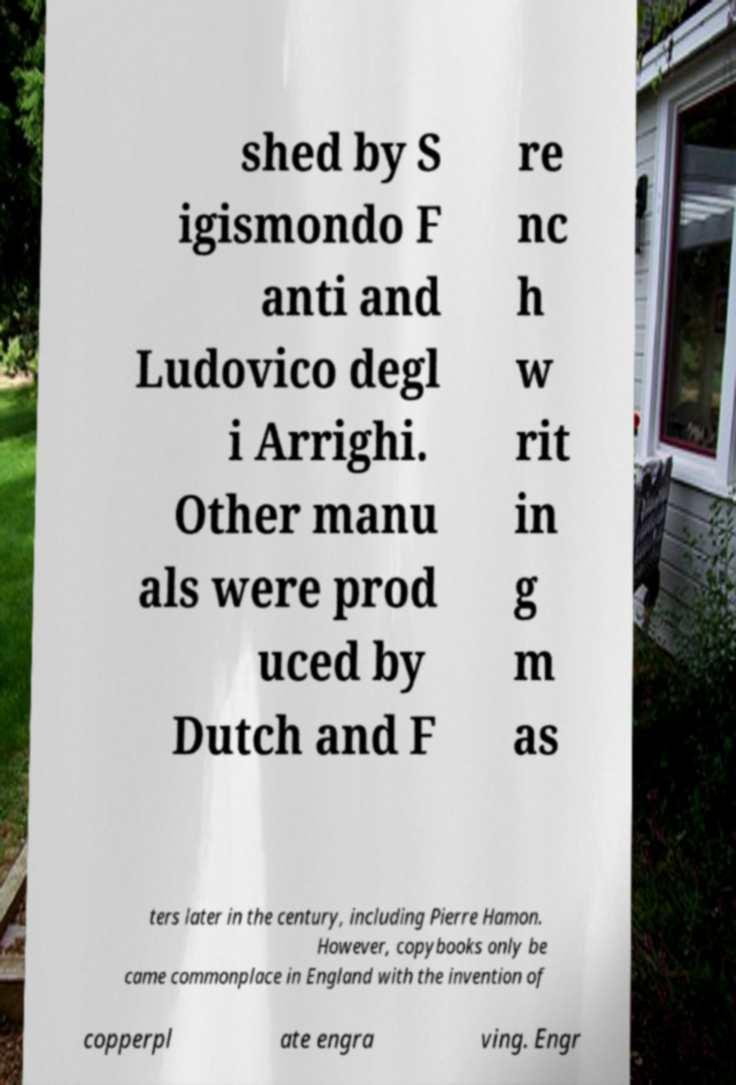Can you read and provide the text displayed in the image?This photo seems to have some interesting text. Can you extract and type it out for me? shed by S igismondo F anti and Ludovico degl i Arrighi. Other manu als were prod uced by Dutch and F re nc h w rit in g m as ters later in the century, including Pierre Hamon. However, copybooks only be came commonplace in England with the invention of copperpl ate engra ving. Engr 